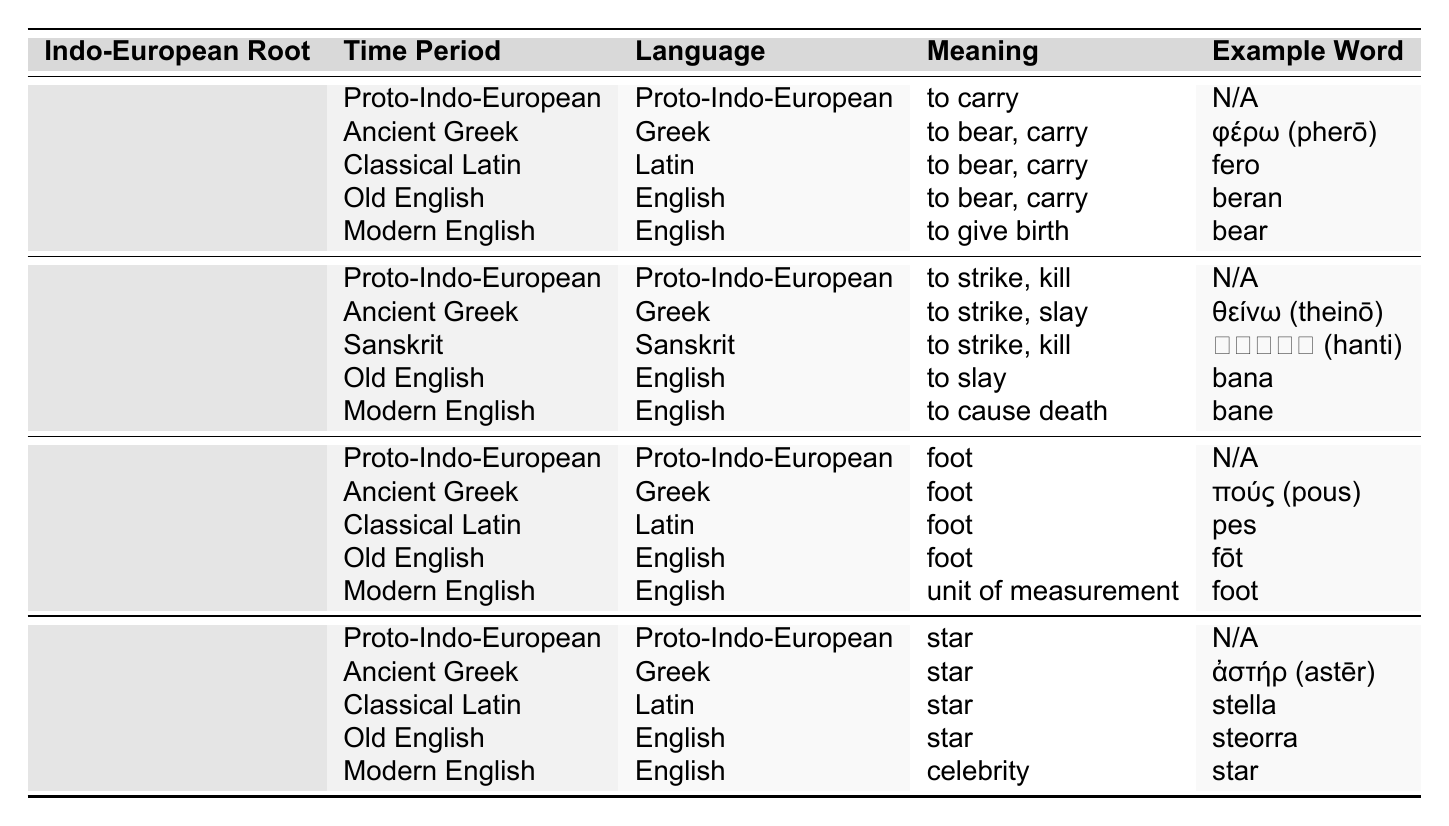What is the meaning of the Indo-European root *bher- in Modern English? According to the table, the meaning of *bher- in Modern English is "to give birth."
Answer: to give birth Which language shows the meaning "to strike, slay" for the root *gwhen-? The Ancient Greek language uses the meaning "to strike, slay" for the root *gwhen-, as listed in the table.
Answer: Ancient Greek How many roots in the table have meanings related to carrying or bearing? The root *bher- appears in the table with meanings related to carrying or bearing in multiple languages, specifically Proto-Indo-European, Ancient Greek, Classical Latin, Old English, and Modern English. Therefore, there is one root with multiple meanings in this context.
Answer: 1 What is the example word given for the Indo-European root *ped- in Old English? The Old English word listed for the root *ped- is "fōt," which means foot.
Answer: fōt Is it true that the root *h₂ster- in Modern English means "star"? No, the root *h₂ster- in Modern English means "celebrity," not "star." According to the table, "star" refers to earlier interpretations of this root in previous languages.
Answer: False What shifted meaning for the root *gwhen- from Old English to Modern English? The root *gwhen- shifted from the meaning "to slay" in Old English to "to cause death" in Modern English, indicating an evolution in connotation over time.
Answer: "to slay" to "to cause death" Which Indo-European root has the most shifts in meaning as shown in the table? The root *bher- shows a clear evolution from "to carry" in Proto-Indo-European to "to give birth" in Modern English, indicating multiple shifts across different languages.
Answer: *bher- In which language does the Indo-European root *ped- mean "unit of measurement"? In Modern English, the root *ped- has taken on the meaning "unit of measurement," as explicitly stated in the table.
Answer: Modern English What is the chronological positioning of the meaning of the Indo-European root *h₂ster- as per the table? The meanings of the root *h₂ster- have remained focused on celestial imagery, evolving from "star" in Proto-Indo-European to "celebrity" in Modern English across various languages.
Answer: Evolving from "star" to "celebrity" Is there a change in the meaning of the root *gwhen- across the languages listed? Yes, there is a gradual change from a direct, violent interpretation of "to strike, kill" to a broader and possibly metaphorical use of "to cause death," indicating a shift in usage context over time.
Answer: Yes 